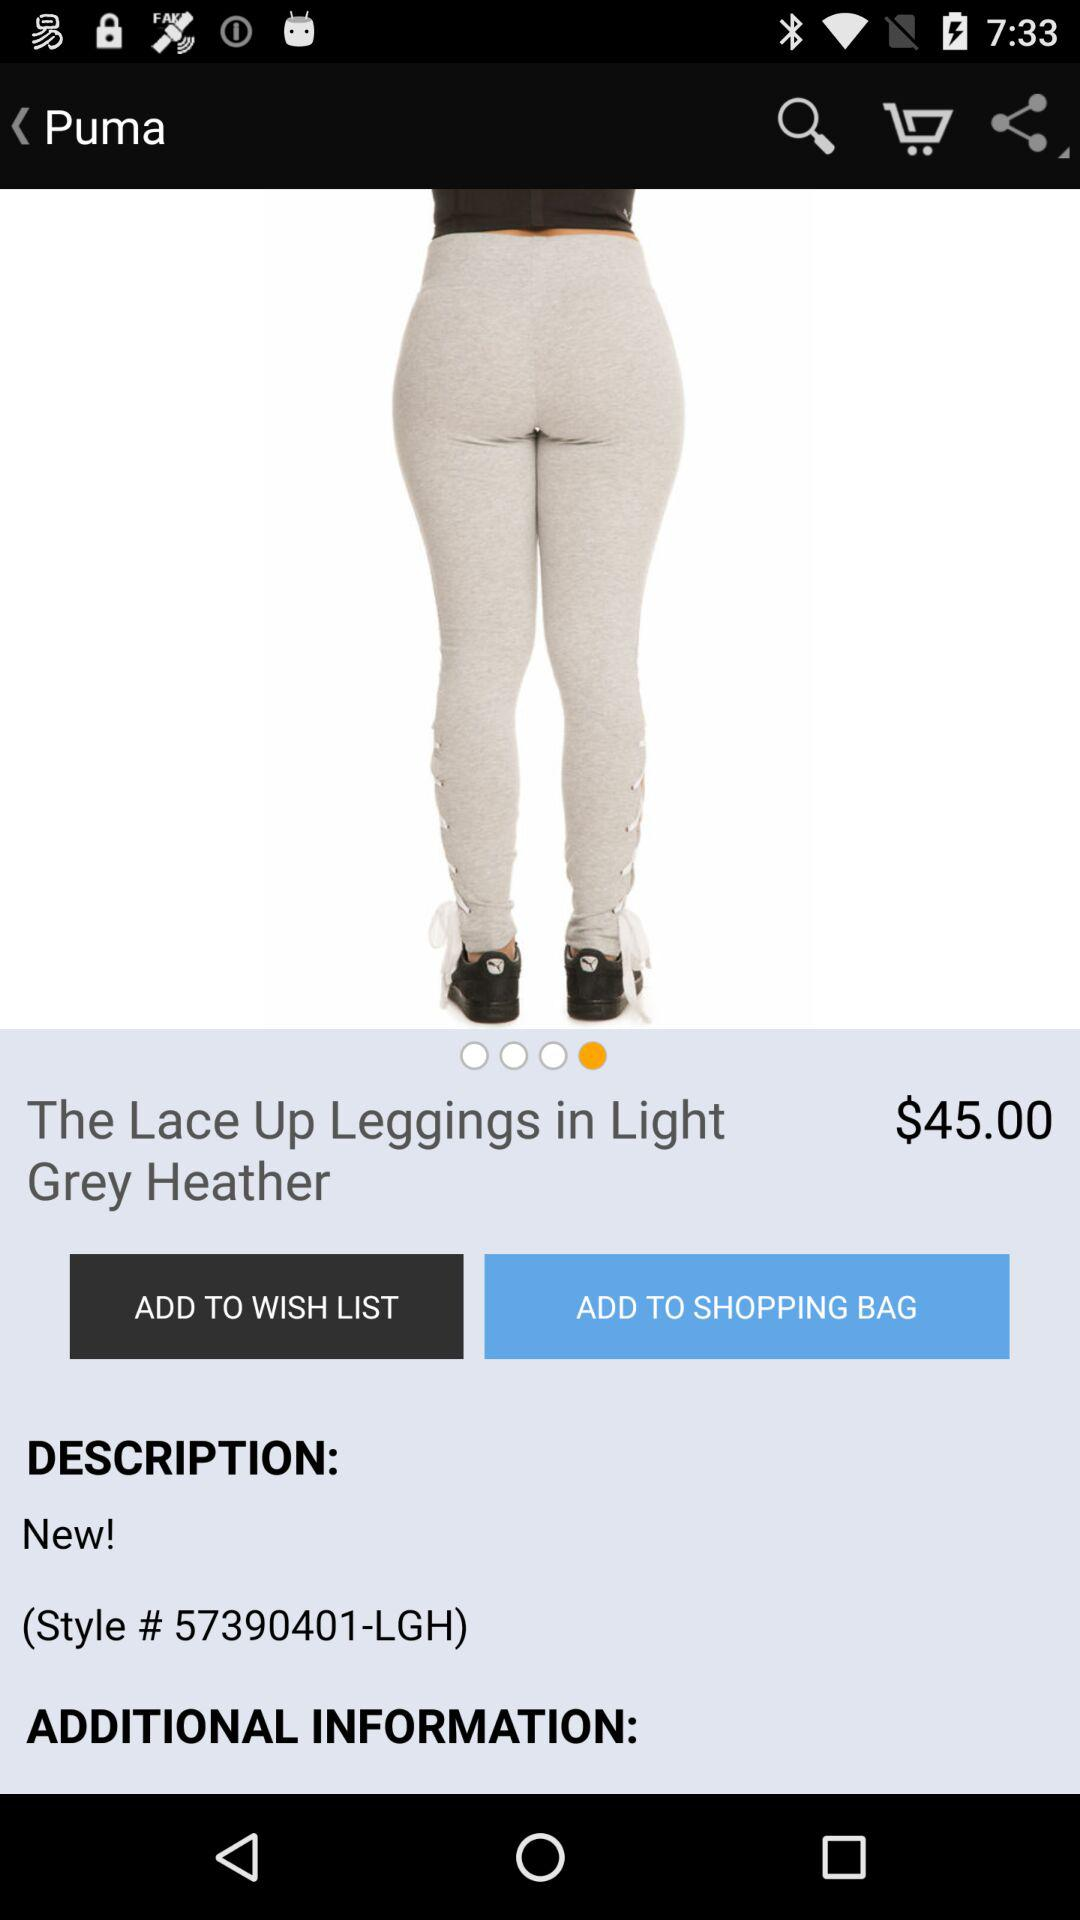What is the style code? The style code is "57390401-LGH". 